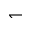<formula> <loc_0><loc_0><loc_500><loc_500>\leftharpoondown</formula> 